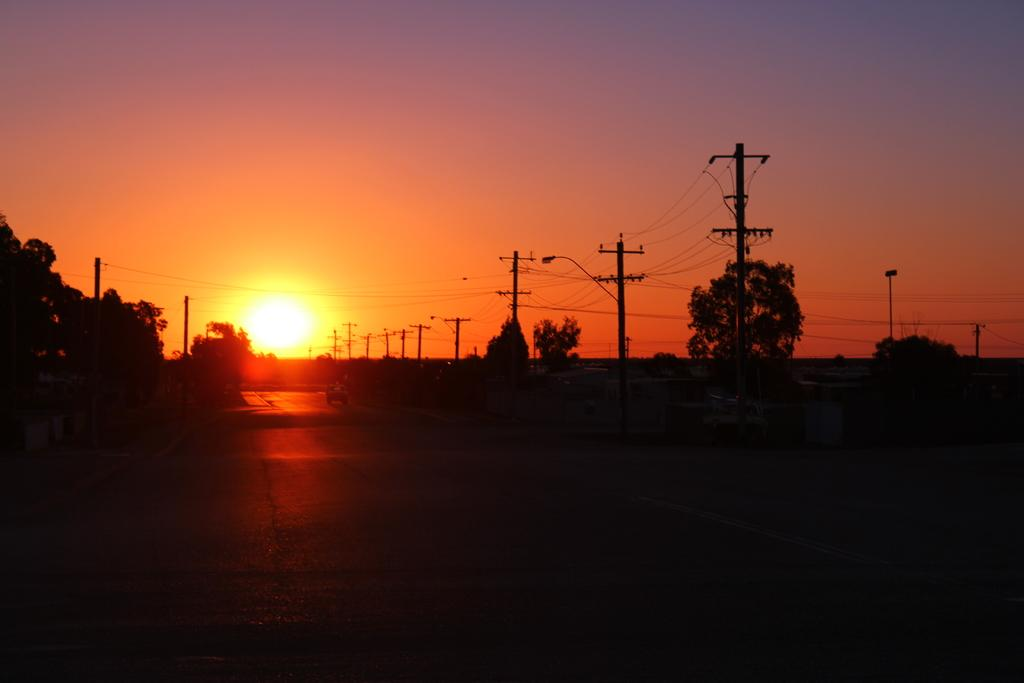What type of natural elements can be seen in the image? There are trees in the image. What man-made structures are present in the image? There are electric poles with wires in the image. What part of the natural environment is visible in the image? The sky is visible in the background of the image. How would you describe the overall appearance of the image? The image has a dark appearance. What type of shoe can be seen on the tree in the image? There is no shoe present on the tree in the image. Who is the father of the person standing near the electric poles in the image? There is no person standing near the electric poles in the image, and therefore no father can be identified. 